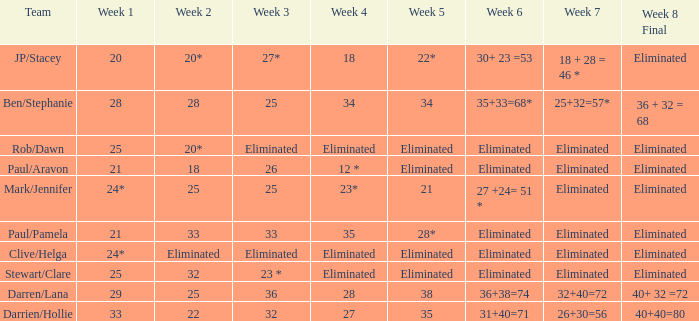Name the week 3 of 36 29.0. 